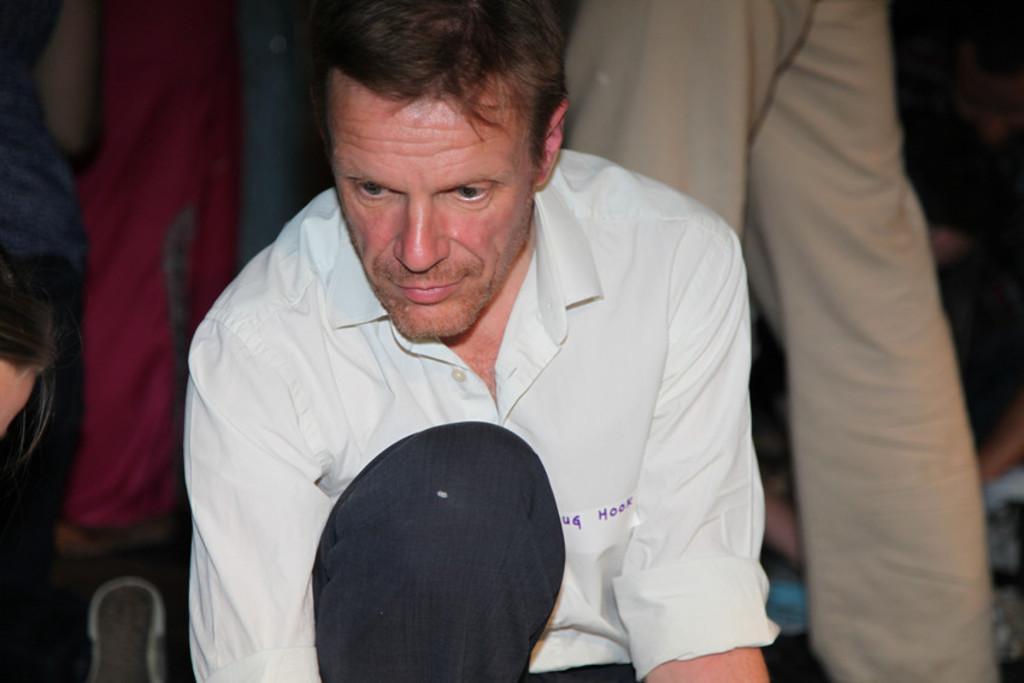Could you give a brief overview of what you see in this image? In this image, there is a person and we can see some text on the sticker, which is on his shirt. In the background, there are some other people. 